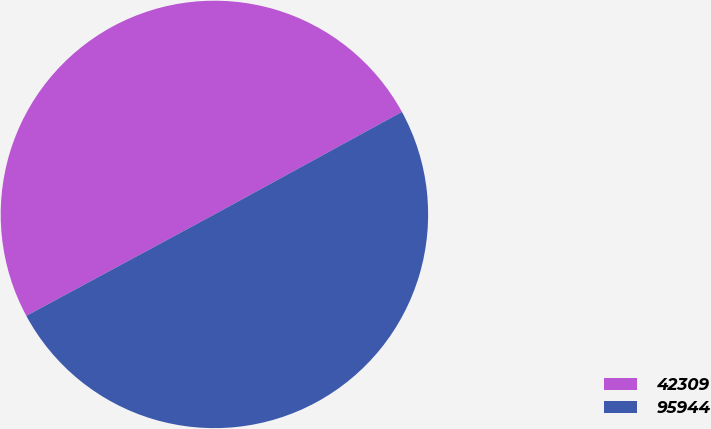<chart> <loc_0><loc_0><loc_500><loc_500><pie_chart><fcel>42309<fcel>95944<nl><fcel>49.91%<fcel>50.09%<nl></chart> 